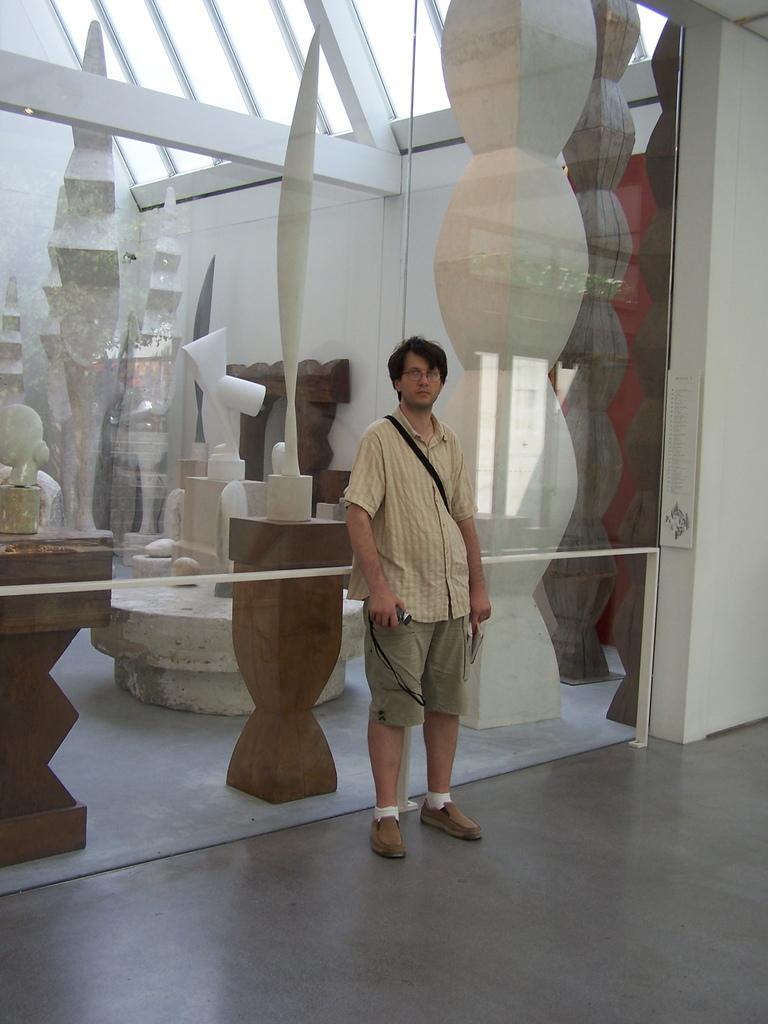What is the main subject in the center of the image? There is a person standing in the center of the image. What can be seen behind the person? There are many objects behind the person. Where is the well located in the image? The well is on the right side of the image. What is visible at the top of the image? The top of the image shows a ceiling. How much wealth is represented by the chin of the person in the image? There is no indication of wealth or a chin in the image; it only shows a person standing in the center and other objects in the background. 